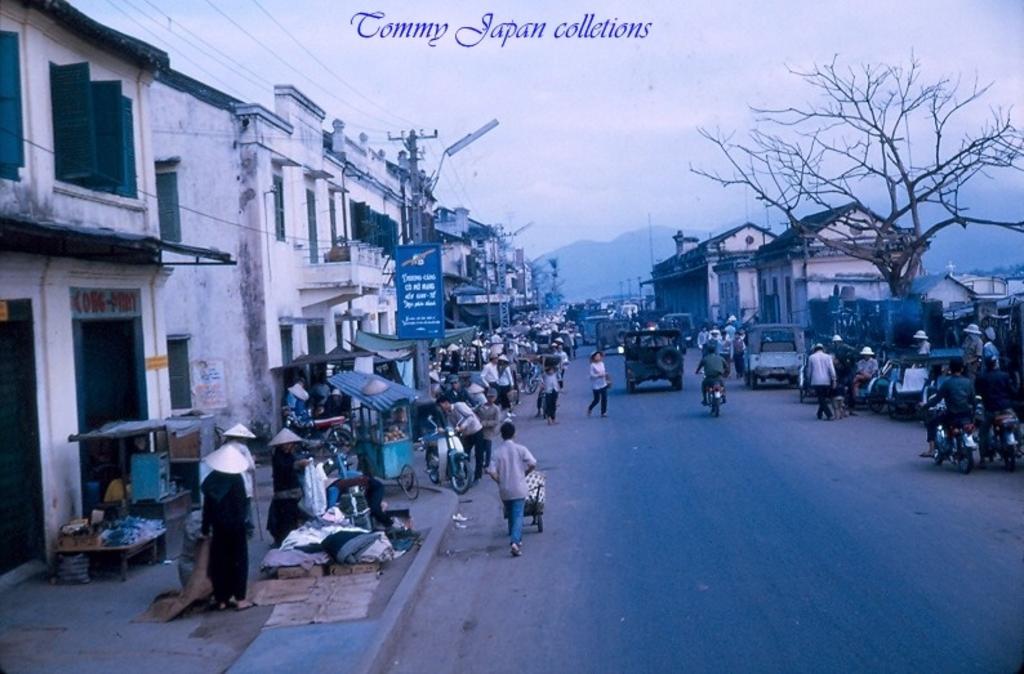Describe this image in one or two sentences. In this image we can see jeeps, bikes and human are moving on the road. To the both sides of the road, buildings are there. Right side of the image we can see one tree. Left side of the image, pavement is there. On the pavement, small shops and people are present. And one electric pole and wires are there. The sky is covered with clouds. 